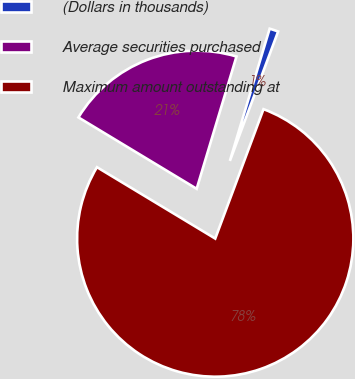<chart> <loc_0><loc_0><loc_500><loc_500><pie_chart><fcel>(Dollars in thousands)<fcel>Average securities purchased<fcel>Maximum amount outstanding at<nl><fcel>1.03%<fcel>21.01%<fcel>77.97%<nl></chart> 